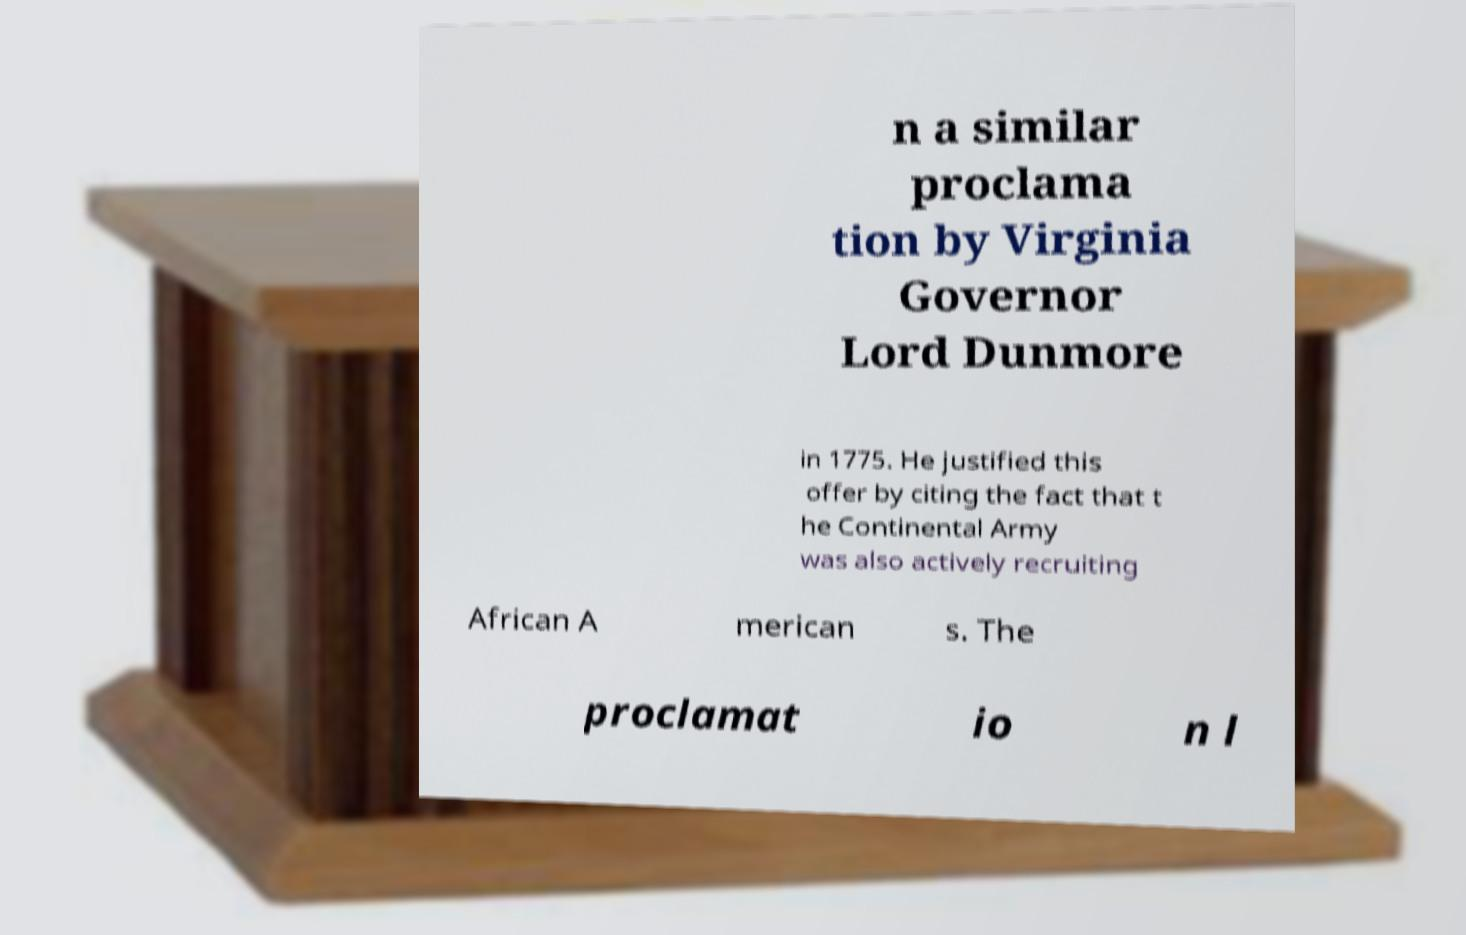Could you assist in decoding the text presented in this image and type it out clearly? n a similar proclama tion by Virginia Governor Lord Dunmore in 1775. He justified this offer by citing the fact that t he Continental Army was also actively recruiting African A merican s. The proclamat io n l 